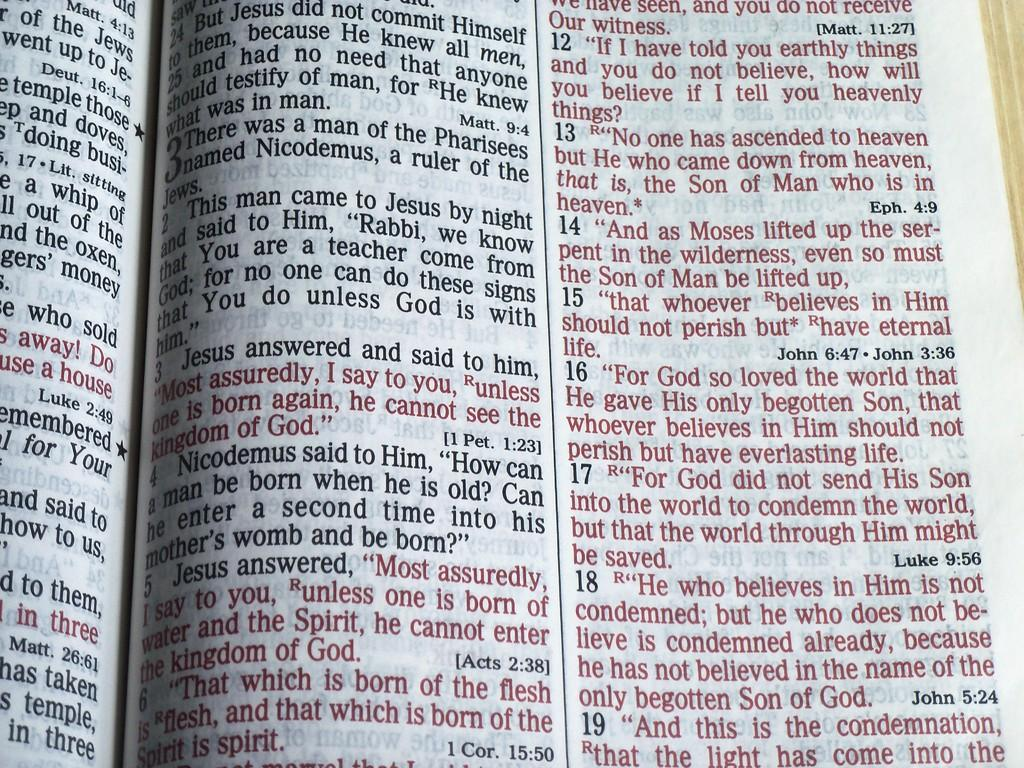<image>
Give a short and clear explanation of the subsequent image. open bible and one of the passages starts with This man came to Jesus by night and said to Him 